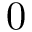Convert formula to latex. <formula><loc_0><loc_0><loc_500><loc_500>0</formula> 